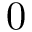Convert formula to latex. <formula><loc_0><loc_0><loc_500><loc_500>0</formula> 